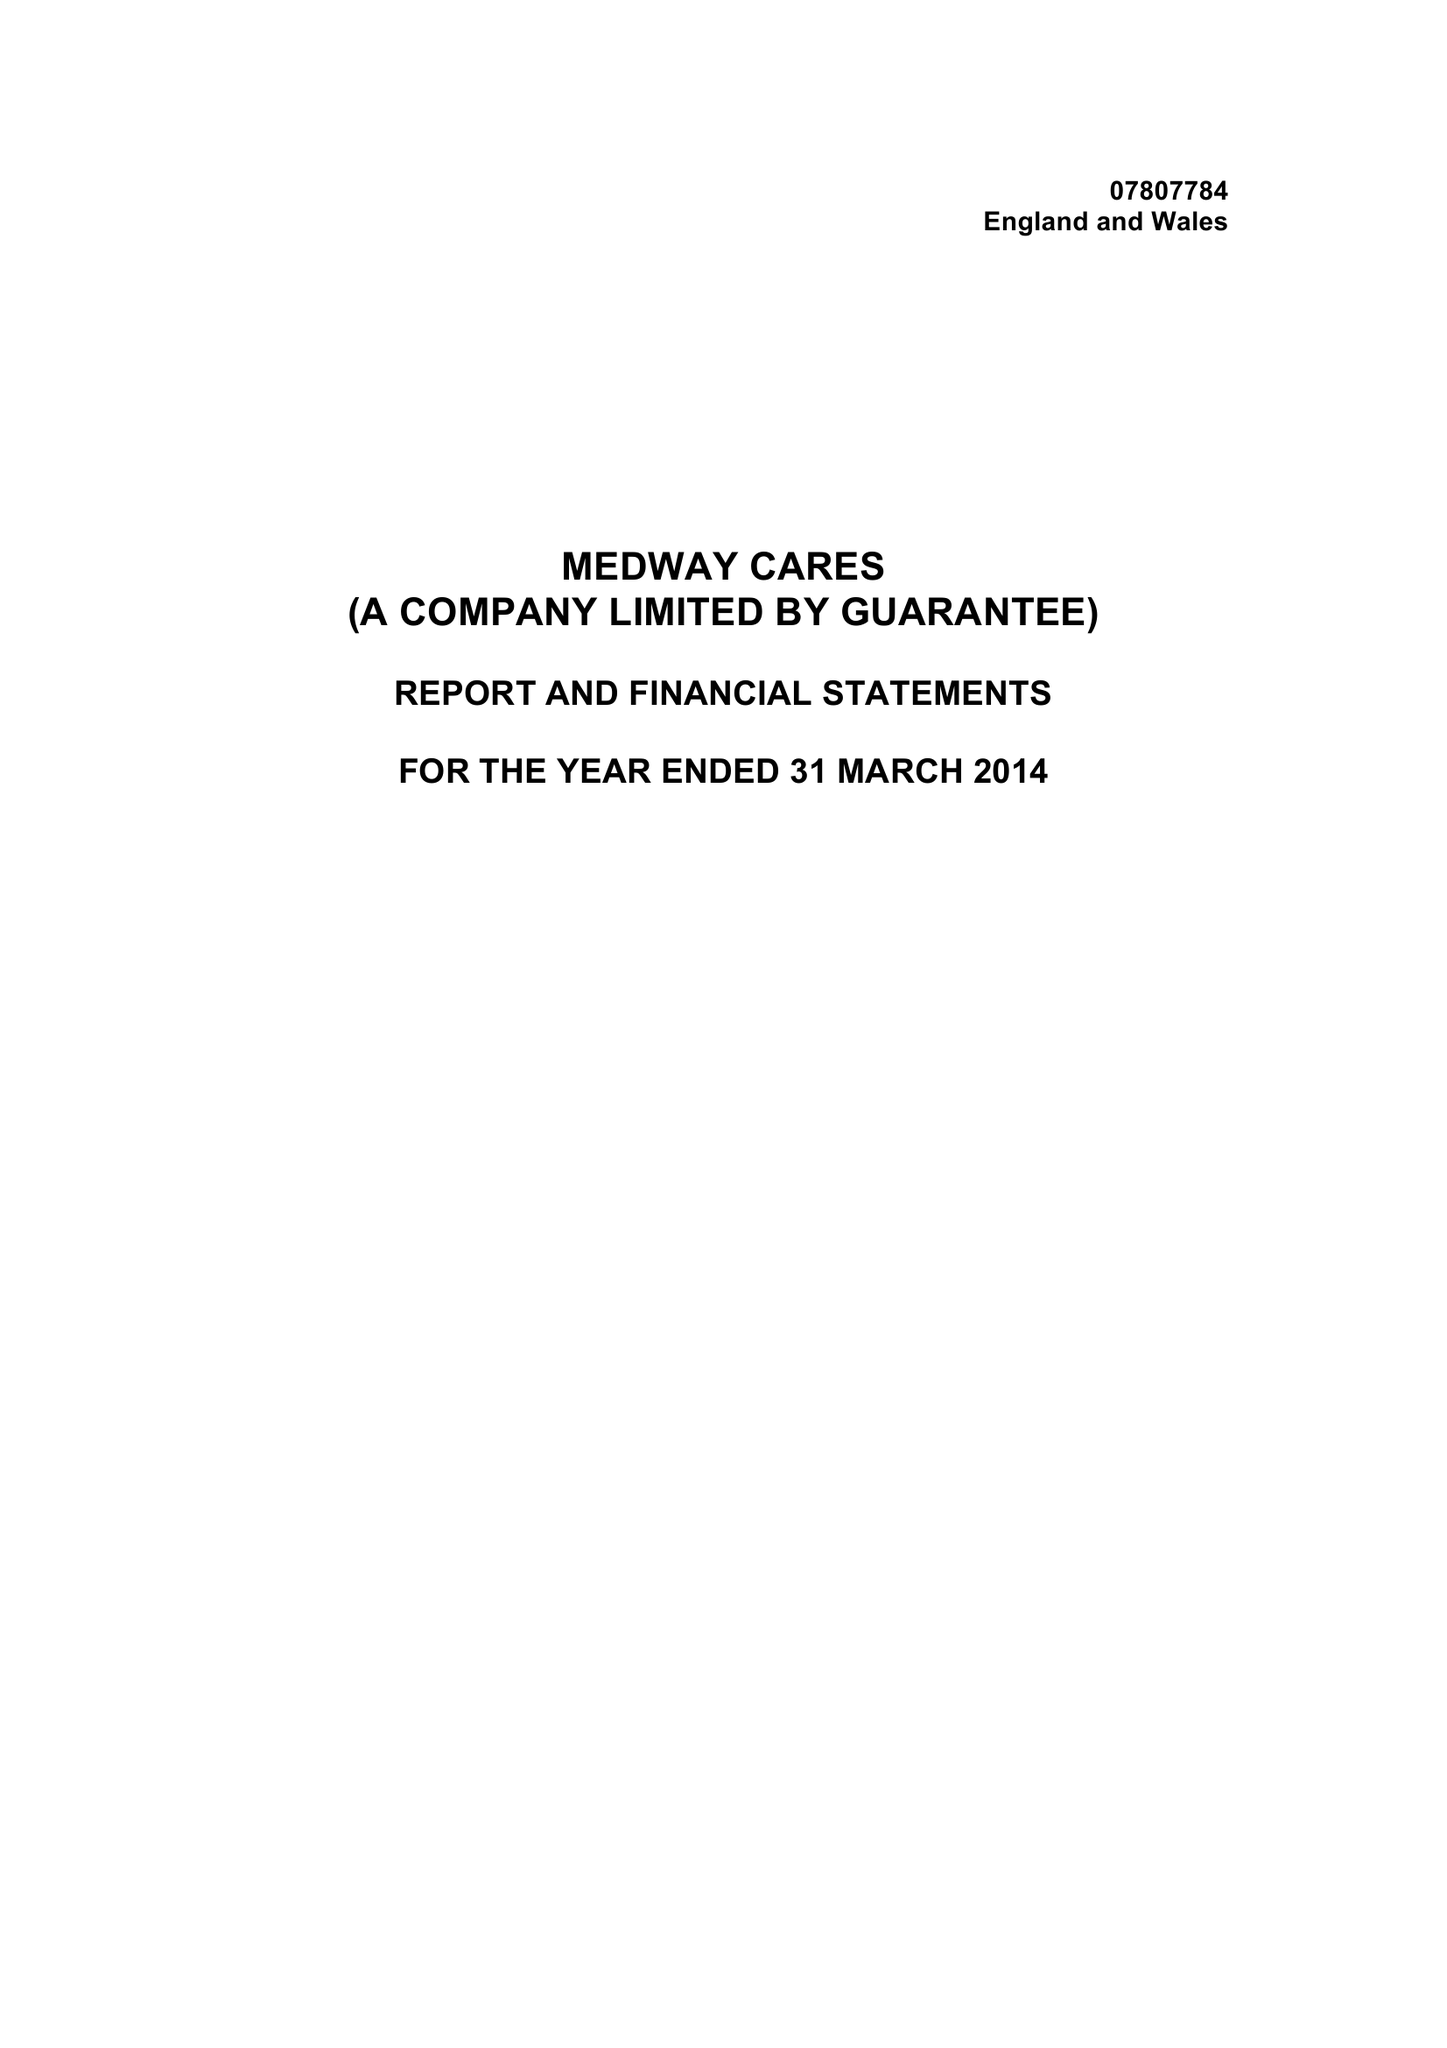What is the value for the address__post_town?
Answer the question using a single word or phrase. GILLINGHAM 